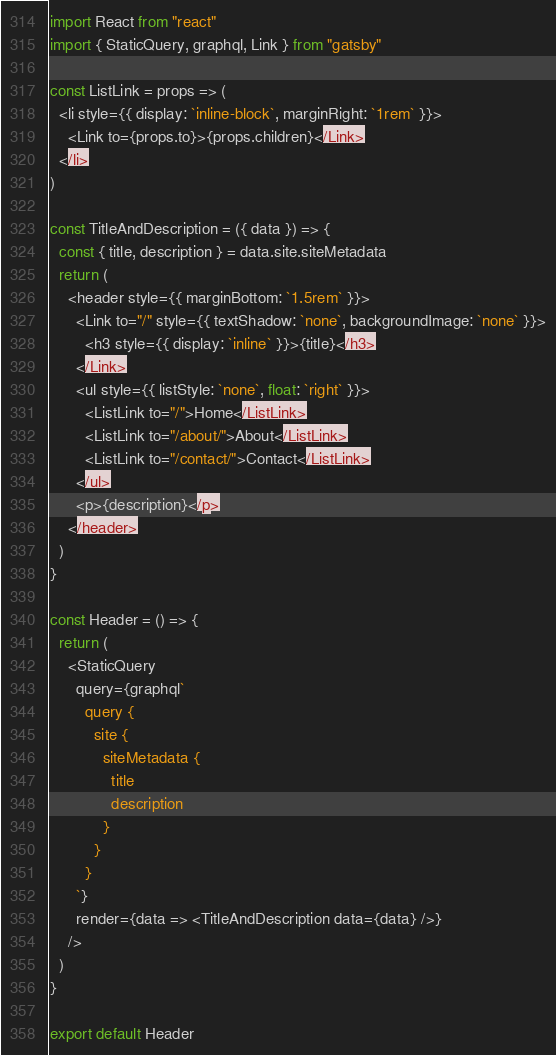<code> <loc_0><loc_0><loc_500><loc_500><_JavaScript_>import React from "react"
import { StaticQuery, graphql, Link } from "gatsby"

const ListLink = props => (
  <li style={{ display: `inline-block`, marginRight: `1rem` }}>
    <Link to={props.to}>{props.children}</Link>
  </li>
)

const TitleAndDescription = ({ data }) => {
  const { title, description } = data.site.siteMetadata
  return (
    <header style={{ marginBottom: `1.5rem` }}>
      <Link to="/" style={{ textShadow: `none`, backgroundImage: `none` }}>
        <h3 style={{ display: `inline` }}>{title}</h3>
      </Link>
      <ul style={{ listStyle: `none`, float: `right` }}>
        <ListLink to="/">Home</ListLink>
        <ListLink to="/about/">About</ListLink>
        <ListLink to="/contact/">Contact</ListLink>
      </ul>
      <p>{description}</p>
    </header>
  )
}

const Header = () => {
  return (
    <StaticQuery
      query={graphql`
        query {
          site {
            siteMetadata {
              title
              description
            }
          }
        }
      `}
      render={data => <TitleAndDescription data={data} />}
    />
  )
}

export default Header
</code> 